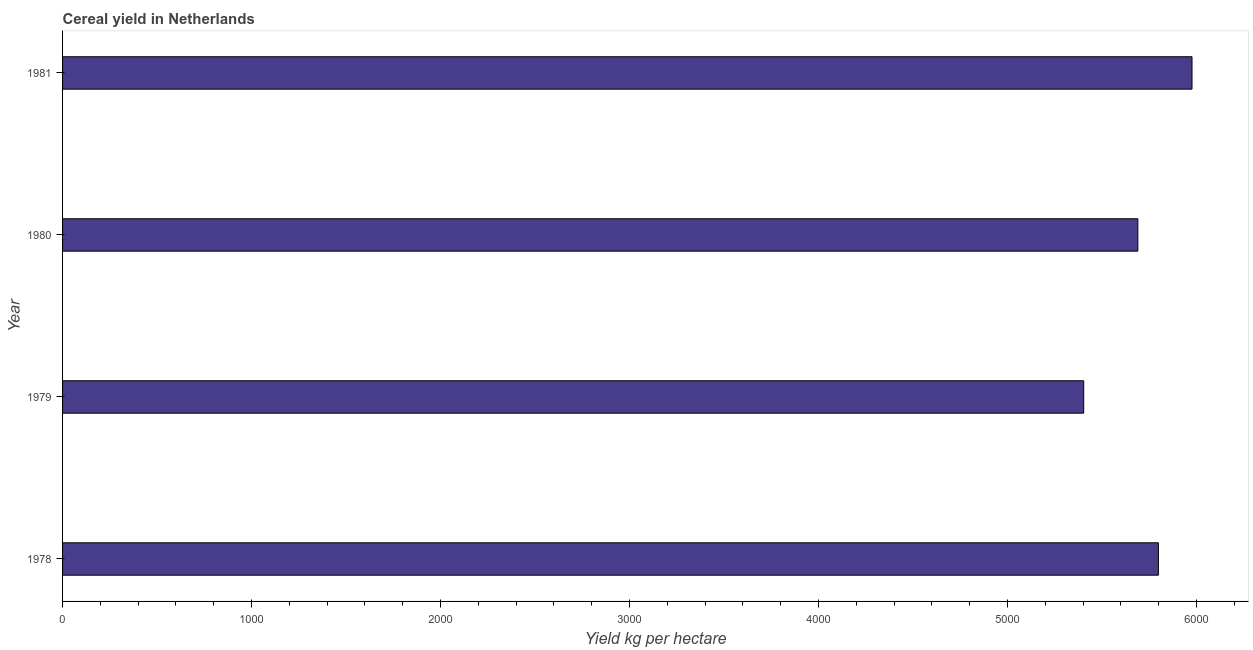What is the title of the graph?
Provide a short and direct response. Cereal yield in Netherlands. What is the label or title of the X-axis?
Offer a terse response. Yield kg per hectare. What is the cereal yield in 1979?
Your answer should be very brief. 5402.72. Across all years, what is the maximum cereal yield?
Provide a succinct answer. 5975.86. Across all years, what is the minimum cereal yield?
Your answer should be compact. 5402.72. In which year was the cereal yield minimum?
Your answer should be compact. 1979. What is the sum of the cereal yield?
Provide a short and direct response. 2.29e+04. What is the difference between the cereal yield in 1978 and 1979?
Your answer should be very brief. 395.2. What is the average cereal yield per year?
Ensure brevity in your answer.  5716.43. What is the median cereal yield?
Your answer should be compact. 5743.56. In how many years, is the cereal yield greater than 4000 kg per hectare?
Provide a succinct answer. 4. Do a majority of the years between 1980 and 1978 (inclusive) have cereal yield greater than 4000 kg per hectare?
Provide a short and direct response. Yes. Is the difference between the cereal yield in 1978 and 1981 greater than the difference between any two years?
Your answer should be very brief. No. What is the difference between the highest and the second highest cereal yield?
Offer a terse response. 177.94. What is the difference between the highest and the lowest cereal yield?
Provide a short and direct response. 573.14. How many years are there in the graph?
Your answer should be very brief. 4. What is the difference between two consecutive major ticks on the X-axis?
Provide a succinct answer. 1000. What is the Yield kg per hectare of 1978?
Provide a short and direct response. 5797.92. What is the Yield kg per hectare in 1979?
Give a very brief answer. 5402.72. What is the Yield kg per hectare of 1980?
Offer a very short reply. 5689.19. What is the Yield kg per hectare in 1981?
Your answer should be very brief. 5975.86. What is the difference between the Yield kg per hectare in 1978 and 1979?
Make the answer very short. 395.2. What is the difference between the Yield kg per hectare in 1978 and 1980?
Provide a succinct answer. 108.72. What is the difference between the Yield kg per hectare in 1978 and 1981?
Keep it short and to the point. -177.94. What is the difference between the Yield kg per hectare in 1979 and 1980?
Give a very brief answer. -286.47. What is the difference between the Yield kg per hectare in 1979 and 1981?
Give a very brief answer. -573.14. What is the difference between the Yield kg per hectare in 1980 and 1981?
Keep it short and to the point. -286.67. What is the ratio of the Yield kg per hectare in 1978 to that in 1979?
Make the answer very short. 1.07. What is the ratio of the Yield kg per hectare in 1978 to that in 1980?
Your answer should be very brief. 1.02. What is the ratio of the Yield kg per hectare in 1979 to that in 1981?
Offer a very short reply. 0.9. 